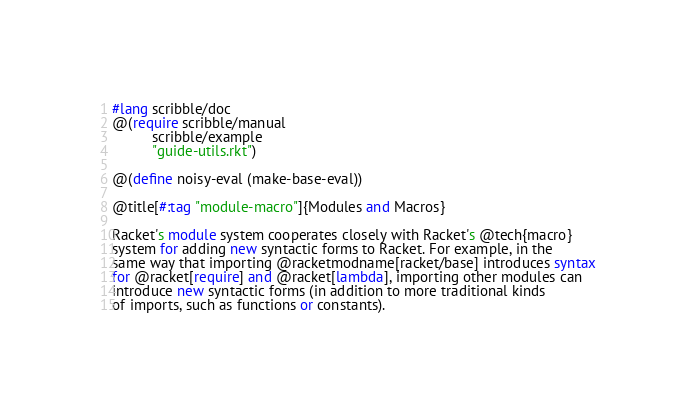<code> <loc_0><loc_0><loc_500><loc_500><_Racket_>#lang scribble/doc
@(require scribble/manual
          scribble/example
          "guide-utils.rkt")

@(define noisy-eval (make-base-eval))

@title[#:tag "module-macro"]{Modules and Macros}

Racket's module system cooperates closely with Racket's @tech{macro}
system for adding new syntactic forms to Racket. For example, in the
same way that importing @racketmodname[racket/base] introduces syntax
for @racket[require] and @racket[lambda], importing other modules can
introduce new syntactic forms (in addition to more traditional kinds
of imports, such as functions or constants).
</code> 